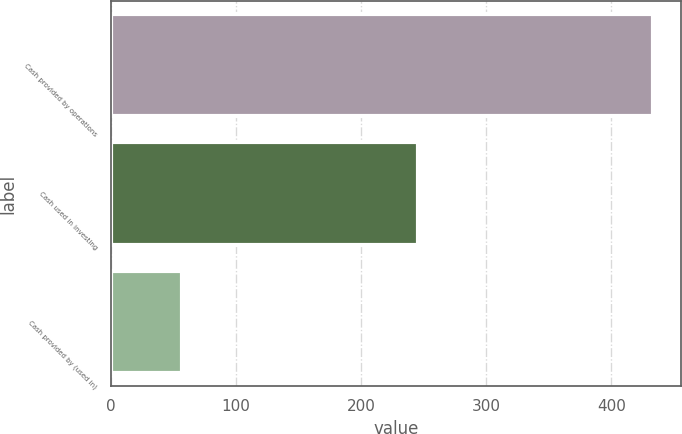Convert chart to OTSL. <chart><loc_0><loc_0><loc_500><loc_500><bar_chart><fcel>Cash provided by operations<fcel>Cash used in investing<fcel>Cash provided by (used in)<nl><fcel>433.5<fcel>245.6<fcel>56.9<nl></chart> 